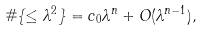Convert formula to latex. <formula><loc_0><loc_0><loc_500><loc_500>\# \{ \leq \lambda ^ { 2 } \} = c _ { 0 } \lambda ^ { n } + O ( \lambda ^ { n - 1 } ) ,</formula> 